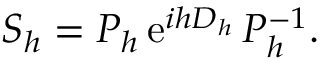<formula> <loc_0><loc_0><loc_500><loc_500>S _ { h } = P _ { h } \, { e } ^ { i h D _ { h } } \, P _ { h } ^ { - 1 } .</formula> 